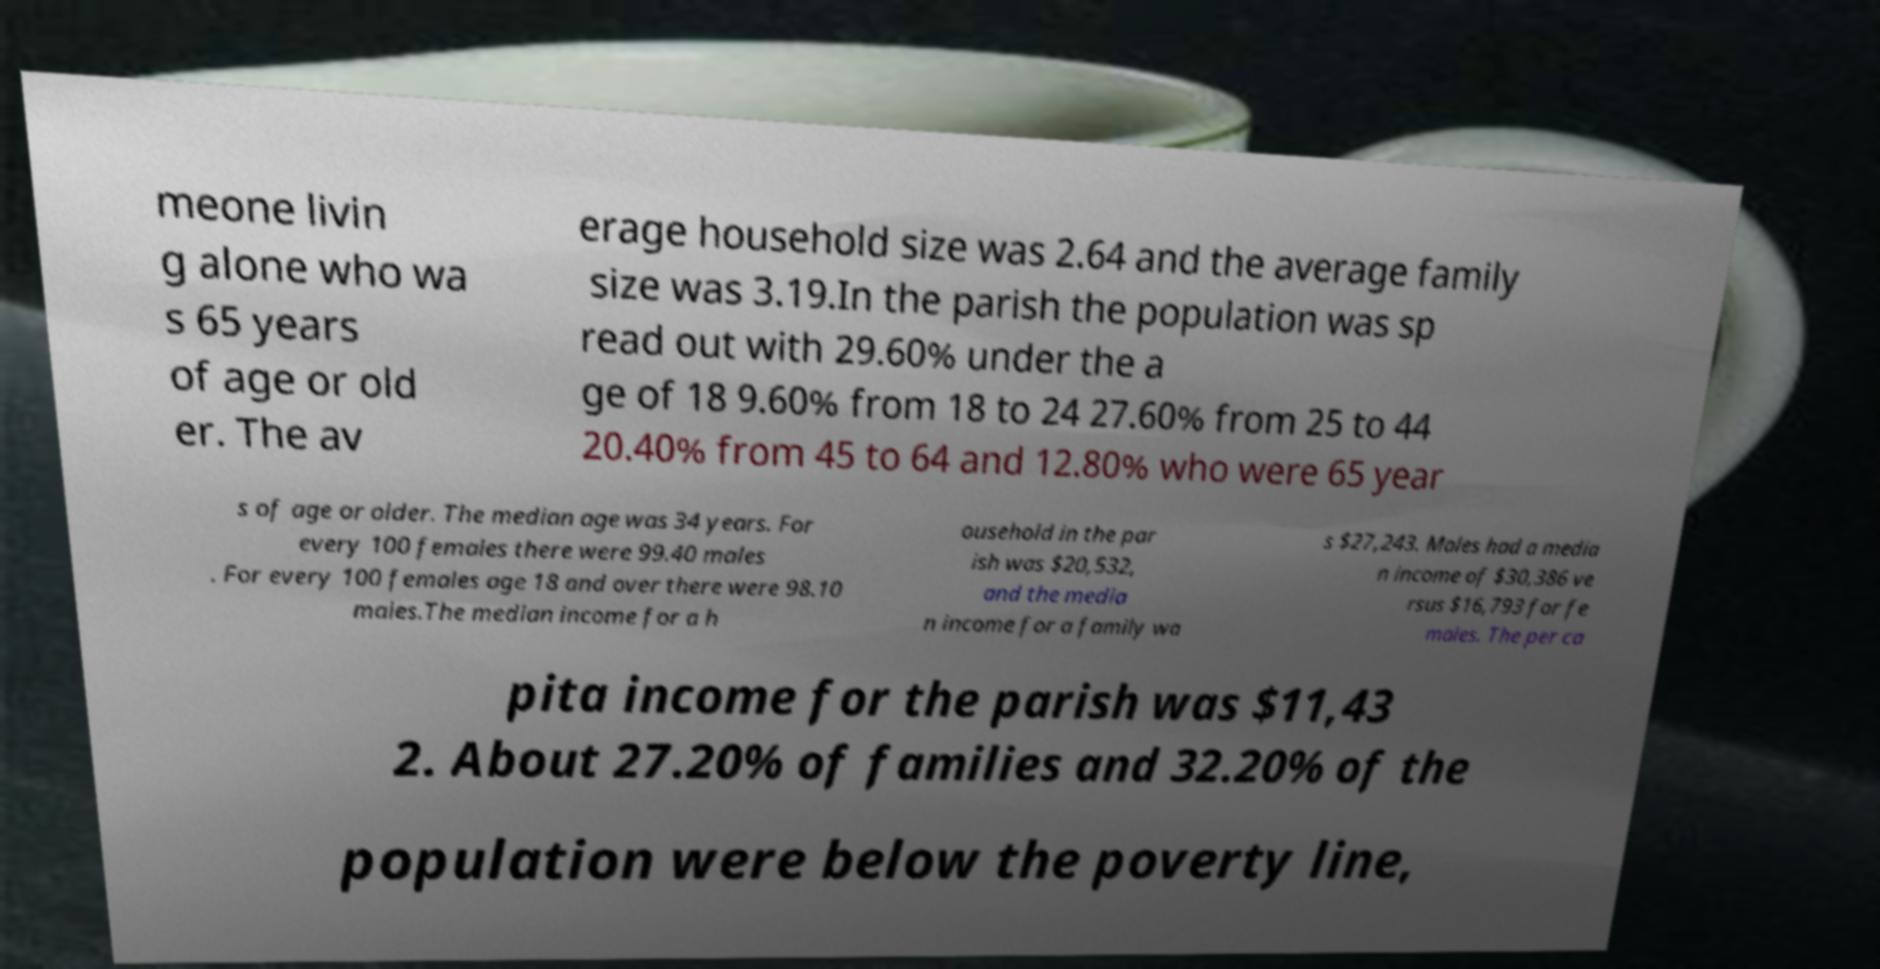For documentation purposes, I need the text within this image transcribed. Could you provide that? meone livin g alone who wa s 65 years of age or old er. The av erage household size was 2.64 and the average family size was 3.19.In the parish the population was sp read out with 29.60% under the a ge of 18 9.60% from 18 to 24 27.60% from 25 to 44 20.40% from 45 to 64 and 12.80% who were 65 year s of age or older. The median age was 34 years. For every 100 females there were 99.40 males . For every 100 females age 18 and over there were 98.10 males.The median income for a h ousehold in the par ish was $20,532, and the media n income for a family wa s $27,243. Males had a media n income of $30,386 ve rsus $16,793 for fe males. The per ca pita income for the parish was $11,43 2. About 27.20% of families and 32.20% of the population were below the poverty line, 